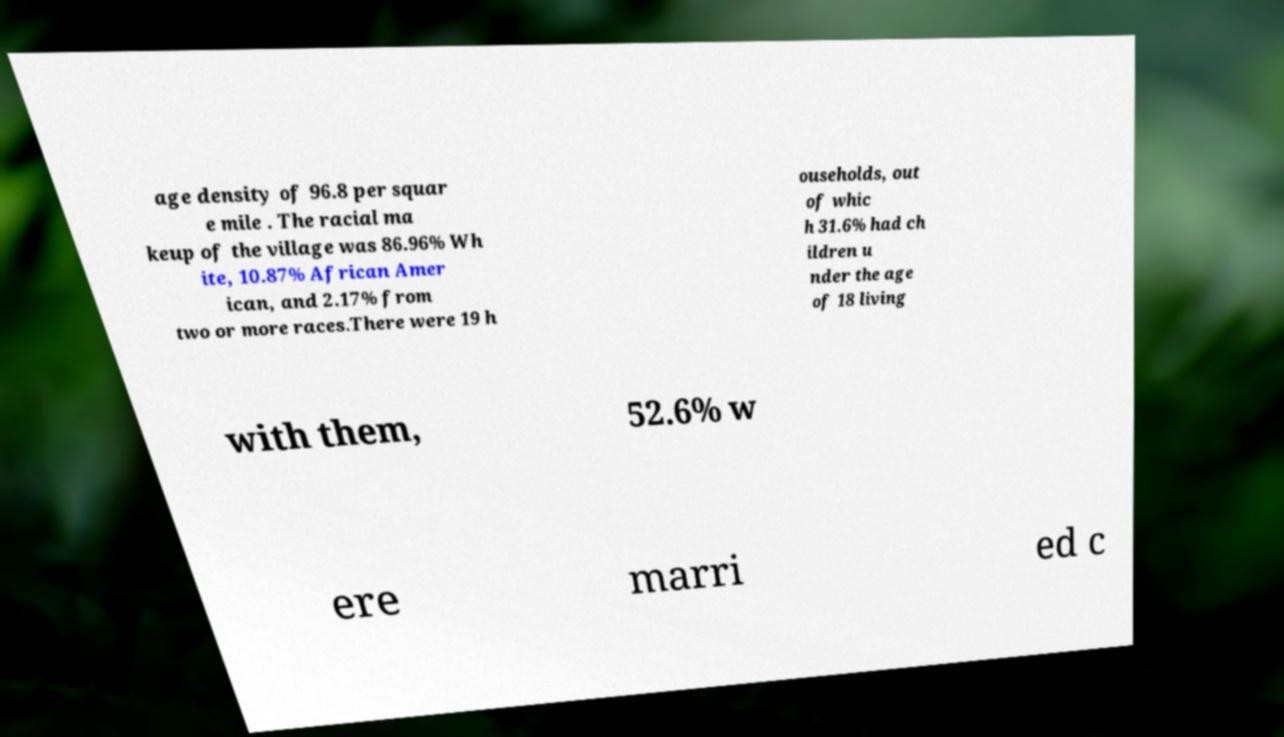There's text embedded in this image that I need extracted. Can you transcribe it verbatim? age density of 96.8 per squar e mile . The racial ma keup of the village was 86.96% Wh ite, 10.87% African Amer ican, and 2.17% from two or more races.There were 19 h ouseholds, out of whic h 31.6% had ch ildren u nder the age of 18 living with them, 52.6% w ere marri ed c 